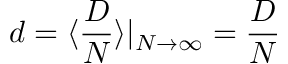Convert formula to latex. <formula><loc_0><loc_0><loc_500><loc_500>d = \langle \frac { D } { N } \rangle | _ { N \to \infty } = \frac { D } { N }</formula> 